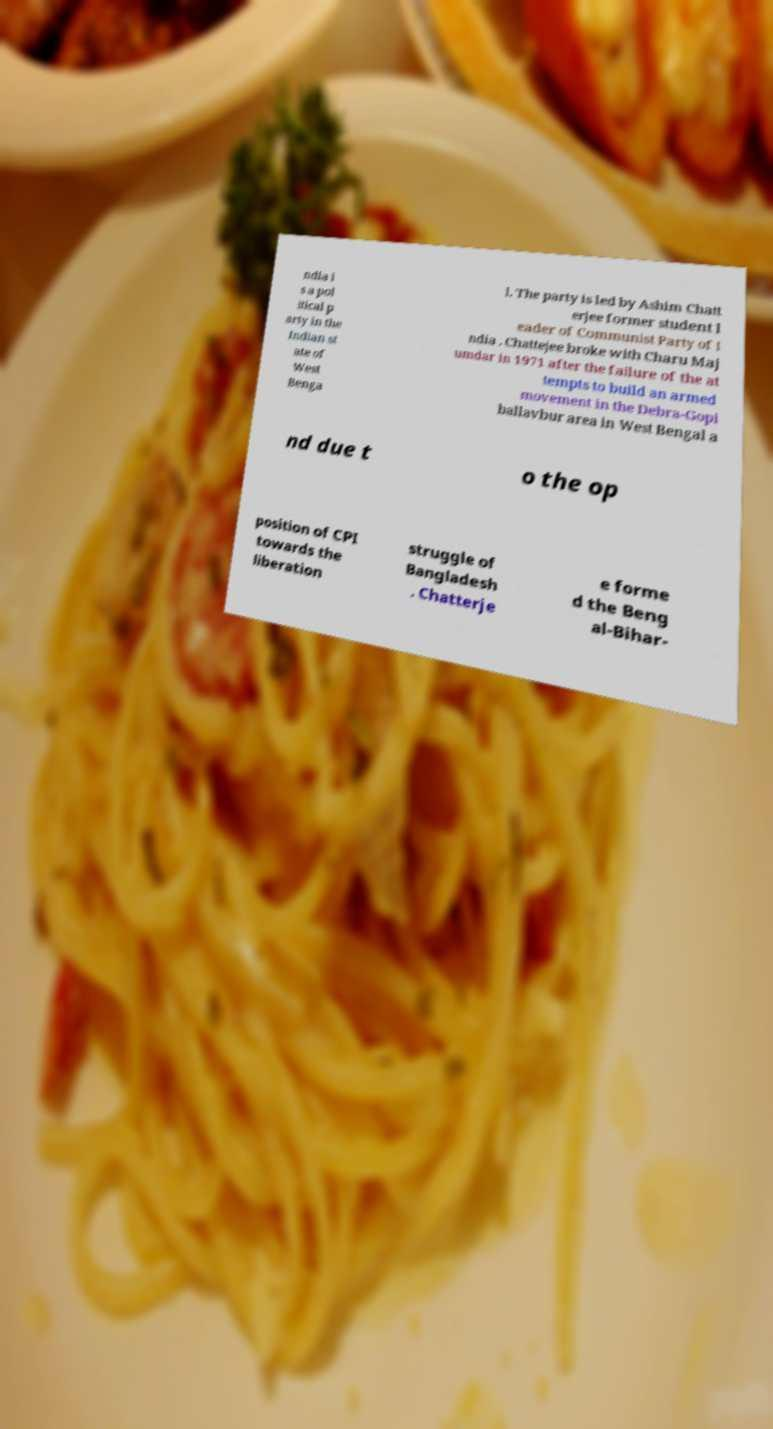Can you accurately transcribe the text from the provided image for me? ndia i s a pol itical p arty in the Indian st ate of West Benga l. The party is led by Ashim Chatt erjee former student l eader of Communist Party of I ndia . Chattejee broke with Charu Maj umdar in 1971 after the failure of the at tempts to build an armed movement in the Debra-Gopi ballavbur area in West Bengal a nd due t o the op position of CPI towards the liberation struggle of Bangladesh . Chatterje e forme d the Beng al-Bihar- 